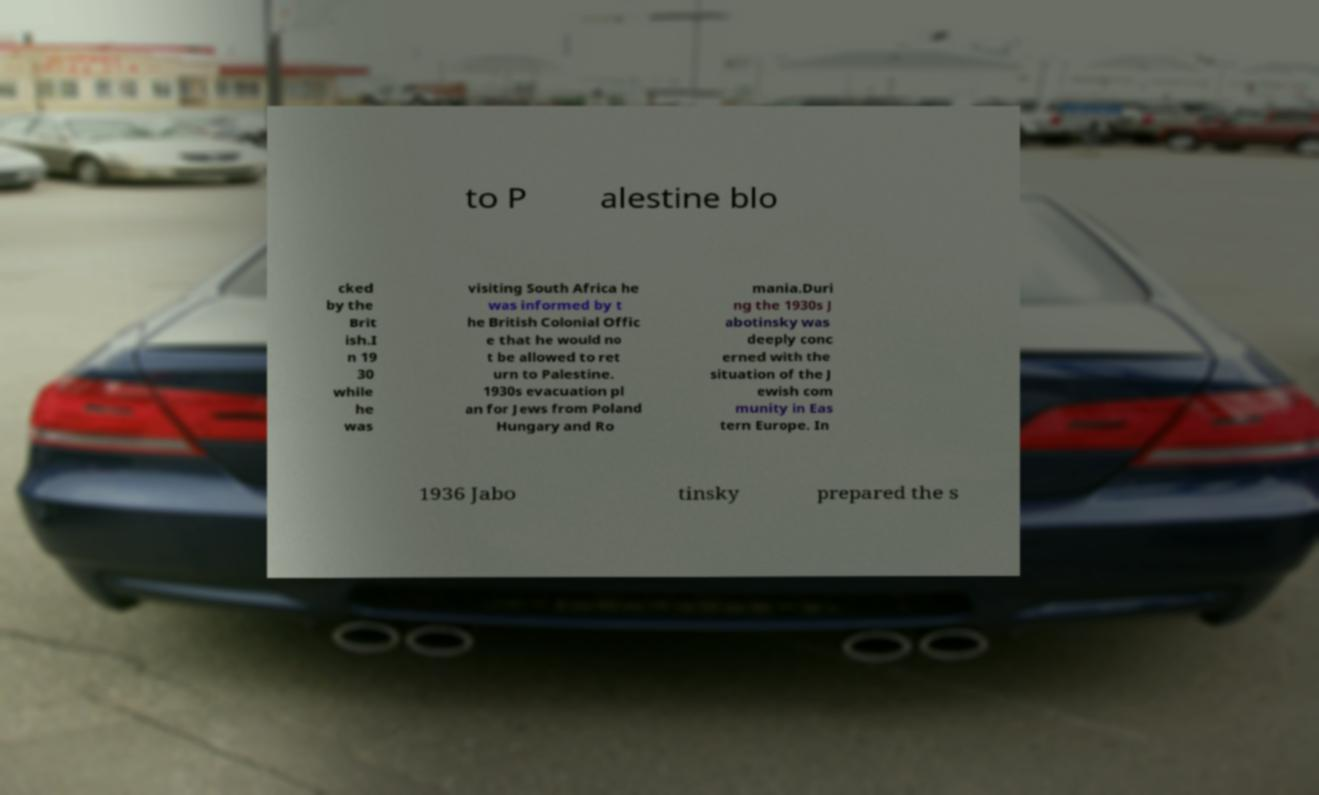Can you accurately transcribe the text from the provided image for me? to P alestine blo cked by the Brit ish.I n 19 30 while he was visiting South Africa he was informed by t he British Colonial Offic e that he would no t be allowed to ret urn to Palestine. 1930s evacuation pl an for Jews from Poland Hungary and Ro mania.Duri ng the 1930s J abotinsky was deeply conc erned with the situation of the J ewish com munity in Eas tern Europe. In 1936 Jabo tinsky prepared the s 